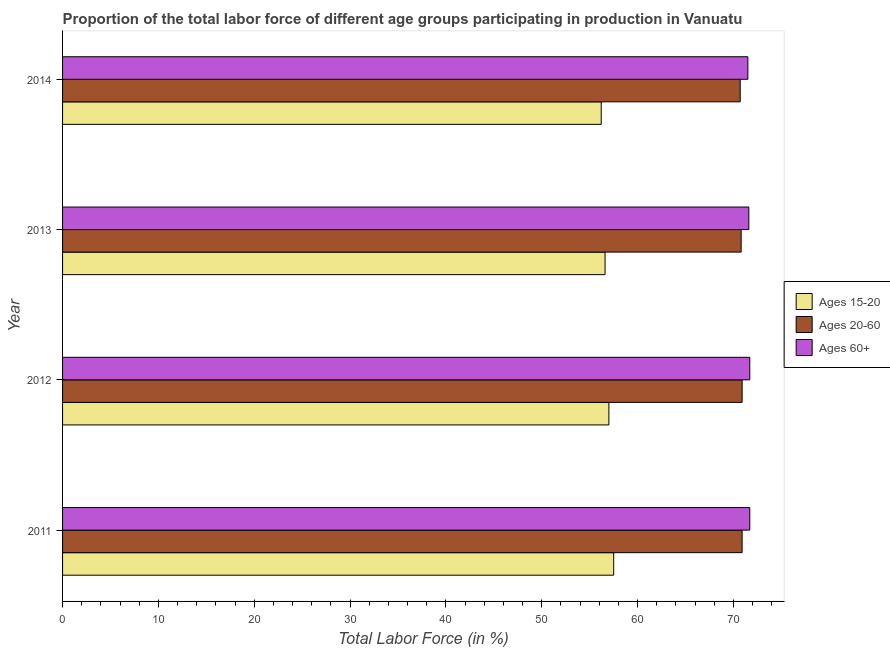How many different coloured bars are there?
Make the answer very short. 3. Are the number of bars on each tick of the Y-axis equal?
Ensure brevity in your answer.  Yes. How many bars are there on the 3rd tick from the bottom?
Keep it short and to the point. 3. What is the label of the 2nd group of bars from the top?
Your response must be concise. 2013. What is the percentage of labor force above age 60 in 2011?
Keep it short and to the point. 71.7. Across all years, what is the maximum percentage of labor force within the age group 20-60?
Give a very brief answer. 70.9. Across all years, what is the minimum percentage of labor force within the age group 15-20?
Make the answer very short. 56.2. In which year was the percentage of labor force within the age group 20-60 maximum?
Provide a short and direct response. 2011. What is the total percentage of labor force within the age group 20-60 in the graph?
Keep it short and to the point. 283.3. What is the difference between the percentage of labor force above age 60 in 2014 and the percentage of labor force within the age group 20-60 in 2012?
Provide a short and direct response. 0.6. What is the average percentage of labor force within the age group 15-20 per year?
Make the answer very short. 56.83. In the year 2014, what is the difference between the percentage of labor force within the age group 15-20 and percentage of labor force above age 60?
Give a very brief answer. -15.3. In how many years, is the percentage of labor force within the age group 20-60 greater than 58 %?
Your answer should be very brief. 4. Is the percentage of labor force within the age group 15-20 in 2011 less than that in 2014?
Give a very brief answer. No. Is the difference between the percentage of labor force above age 60 in 2011 and 2013 greater than the difference between the percentage of labor force within the age group 20-60 in 2011 and 2013?
Your answer should be compact. Yes. What is the difference between the highest and the lowest percentage of labor force above age 60?
Your response must be concise. 0.2. In how many years, is the percentage of labor force within the age group 20-60 greater than the average percentage of labor force within the age group 20-60 taken over all years?
Your answer should be compact. 2. Is the sum of the percentage of labor force above age 60 in 2011 and 2012 greater than the maximum percentage of labor force within the age group 15-20 across all years?
Offer a very short reply. Yes. What does the 1st bar from the top in 2011 represents?
Offer a very short reply. Ages 60+. What does the 1st bar from the bottom in 2011 represents?
Give a very brief answer. Ages 15-20. How many bars are there?
Ensure brevity in your answer.  12. How many years are there in the graph?
Give a very brief answer. 4. Are the values on the major ticks of X-axis written in scientific E-notation?
Keep it short and to the point. No. Does the graph contain grids?
Provide a short and direct response. No. Where does the legend appear in the graph?
Ensure brevity in your answer.  Center right. How many legend labels are there?
Your answer should be very brief. 3. How are the legend labels stacked?
Your answer should be very brief. Vertical. What is the title of the graph?
Your answer should be very brief. Proportion of the total labor force of different age groups participating in production in Vanuatu. What is the Total Labor Force (in %) of Ages 15-20 in 2011?
Offer a very short reply. 57.5. What is the Total Labor Force (in %) in Ages 20-60 in 2011?
Give a very brief answer. 70.9. What is the Total Labor Force (in %) of Ages 60+ in 2011?
Make the answer very short. 71.7. What is the Total Labor Force (in %) in Ages 20-60 in 2012?
Give a very brief answer. 70.9. What is the Total Labor Force (in %) in Ages 60+ in 2012?
Offer a very short reply. 71.7. What is the Total Labor Force (in %) of Ages 15-20 in 2013?
Your answer should be very brief. 56.6. What is the Total Labor Force (in %) of Ages 20-60 in 2013?
Ensure brevity in your answer.  70.8. What is the Total Labor Force (in %) in Ages 60+ in 2013?
Give a very brief answer. 71.6. What is the Total Labor Force (in %) of Ages 15-20 in 2014?
Keep it short and to the point. 56.2. What is the Total Labor Force (in %) in Ages 20-60 in 2014?
Ensure brevity in your answer.  70.7. What is the Total Labor Force (in %) of Ages 60+ in 2014?
Make the answer very short. 71.5. Across all years, what is the maximum Total Labor Force (in %) of Ages 15-20?
Your answer should be very brief. 57.5. Across all years, what is the maximum Total Labor Force (in %) of Ages 20-60?
Keep it short and to the point. 70.9. Across all years, what is the maximum Total Labor Force (in %) of Ages 60+?
Your answer should be compact. 71.7. Across all years, what is the minimum Total Labor Force (in %) of Ages 15-20?
Give a very brief answer. 56.2. Across all years, what is the minimum Total Labor Force (in %) in Ages 20-60?
Your answer should be very brief. 70.7. Across all years, what is the minimum Total Labor Force (in %) of Ages 60+?
Your answer should be very brief. 71.5. What is the total Total Labor Force (in %) of Ages 15-20 in the graph?
Make the answer very short. 227.3. What is the total Total Labor Force (in %) of Ages 20-60 in the graph?
Your answer should be compact. 283.3. What is the total Total Labor Force (in %) in Ages 60+ in the graph?
Give a very brief answer. 286.5. What is the difference between the Total Labor Force (in %) of Ages 20-60 in 2011 and that in 2013?
Provide a succinct answer. 0.1. What is the difference between the Total Labor Force (in %) in Ages 15-20 in 2011 and that in 2014?
Offer a terse response. 1.3. What is the difference between the Total Labor Force (in %) in Ages 20-60 in 2011 and that in 2014?
Ensure brevity in your answer.  0.2. What is the difference between the Total Labor Force (in %) of Ages 60+ in 2012 and that in 2014?
Your answer should be compact. 0.2. What is the difference between the Total Labor Force (in %) of Ages 15-20 in 2011 and the Total Labor Force (in %) of Ages 20-60 in 2012?
Offer a terse response. -13.4. What is the difference between the Total Labor Force (in %) of Ages 15-20 in 2011 and the Total Labor Force (in %) of Ages 60+ in 2012?
Provide a short and direct response. -14.2. What is the difference between the Total Labor Force (in %) of Ages 15-20 in 2011 and the Total Labor Force (in %) of Ages 60+ in 2013?
Provide a short and direct response. -14.1. What is the difference between the Total Labor Force (in %) in Ages 20-60 in 2011 and the Total Labor Force (in %) in Ages 60+ in 2013?
Offer a terse response. -0.7. What is the difference between the Total Labor Force (in %) of Ages 15-20 in 2011 and the Total Labor Force (in %) of Ages 20-60 in 2014?
Your answer should be very brief. -13.2. What is the difference between the Total Labor Force (in %) in Ages 15-20 in 2011 and the Total Labor Force (in %) in Ages 60+ in 2014?
Your response must be concise. -14. What is the difference between the Total Labor Force (in %) in Ages 20-60 in 2011 and the Total Labor Force (in %) in Ages 60+ in 2014?
Your answer should be compact. -0.6. What is the difference between the Total Labor Force (in %) in Ages 15-20 in 2012 and the Total Labor Force (in %) in Ages 60+ in 2013?
Your response must be concise. -14.6. What is the difference between the Total Labor Force (in %) of Ages 20-60 in 2012 and the Total Labor Force (in %) of Ages 60+ in 2013?
Ensure brevity in your answer.  -0.7. What is the difference between the Total Labor Force (in %) of Ages 15-20 in 2012 and the Total Labor Force (in %) of Ages 20-60 in 2014?
Provide a short and direct response. -13.7. What is the difference between the Total Labor Force (in %) of Ages 20-60 in 2012 and the Total Labor Force (in %) of Ages 60+ in 2014?
Ensure brevity in your answer.  -0.6. What is the difference between the Total Labor Force (in %) of Ages 15-20 in 2013 and the Total Labor Force (in %) of Ages 20-60 in 2014?
Provide a short and direct response. -14.1. What is the difference between the Total Labor Force (in %) of Ages 15-20 in 2013 and the Total Labor Force (in %) of Ages 60+ in 2014?
Provide a succinct answer. -14.9. What is the average Total Labor Force (in %) of Ages 15-20 per year?
Provide a succinct answer. 56.83. What is the average Total Labor Force (in %) in Ages 20-60 per year?
Give a very brief answer. 70.83. What is the average Total Labor Force (in %) in Ages 60+ per year?
Ensure brevity in your answer.  71.62. In the year 2011, what is the difference between the Total Labor Force (in %) in Ages 15-20 and Total Labor Force (in %) in Ages 60+?
Your answer should be compact. -14.2. In the year 2011, what is the difference between the Total Labor Force (in %) of Ages 20-60 and Total Labor Force (in %) of Ages 60+?
Your answer should be very brief. -0.8. In the year 2012, what is the difference between the Total Labor Force (in %) in Ages 15-20 and Total Labor Force (in %) in Ages 20-60?
Provide a succinct answer. -13.9. In the year 2012, what is the difference between the Total Labor Force (in %) of Ages 15-20 and Total Labor Force (in %) of Ages 60+?
Ensure brevity in your answer.  -14.7. In the year 2013, what is the difference between the Total Labor Force (in %) in Ages 15-20 and Total Labor Force (in %) in Ages 20-60?
Provide a succinct answer. -14.2. In the year 2013, what is the difference between the Total Labor Force (in %) in Ages 20-60 and Total Labor Force (in %) in Ages 60+?
Ensure brevity in your answer.  -0.8. In the year 2014, what is the difference between the Total Labor Force (in %) of Ages 15-20 and Total Labor Force (in %) of Ages 60+?
Provide a succinct answer. -15.3. What is the ratio of the Total Labor Force (in %) in Ages 15-20 in 2011 to that in 2012?
Give a very brief answer. 1.01. What is the ratio of the Total Labor Force (in %) of Ages 20-60 in 2011 to that in 2012?
Keep it short and to the point. 1. What is the ratio of the Total Labor Force (in %) of Ages 15-20 in 2011 to that in 2013?
Make the answer very short. 1.02. What is the ratio of the Total Labor Force (in %) of Ages 20-60 in 2011 to that in 2013?
Offer a terse response. 1. What is the ratio of the Total Labor Force (in %) in Ages 15-20 in 2011 to that in 2014?
Give a very brief answer. 1.02. What is the ratio of the Total Labor Force (in %) of Ages 20-60 in 2011 to that in 2014?
Keep it short and to the point. 1. What is the ratio of the Total Labor Force (in %) of Ages 60+ in 2011 to that in 2014?
Keep it short and to the point. 1. What is the ratio of the Total Labor Force (in %) of Ages 15-20 in 2012 to that in 2013?
Provide a short and direct response. 1.01. What is the ratio of the Total Labor Force (in %) in Ages 15-20 in 2012 to that in 2014?
Provide a short and direct response. 1.01. What is the ratio of the Total Labor Force (in %) of Ages 15-20 in 2013 to that in 2014?
Make the answer very short. 1.01. What is the ratio of the Total Labor Force (in %) in Ages 20-60 in 2013 to that in 2014?
Make the answer very short. 1. What is the difference between the highest and the second highest Total Labor Force (in %) of Ages 15-20?
Provide a short and direct response. 0.5. What is the difference between the highest and the second highest Total Labor Force (in %) of Ages 20-60?
Your answer should be compact. 0. What is the difference between the highest and the second highest Total Labor Force (in %) of Ages 60+?
Your answer should be compact. 0. What is the difference between the highest and the lowest Total Labor Force (in %) in Ages 60+?
Provide a succinct answer. 0.2. 